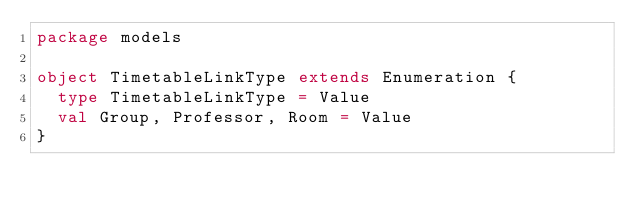Convert code to text. <code><loc_0><loc_0><loc_500><loc_500><_Scala_>package models

object TimetableLinkType extends Enumeration {
  type TimetableLinkType = Value
  val Group, Professor, Room = Value
}
</code> 